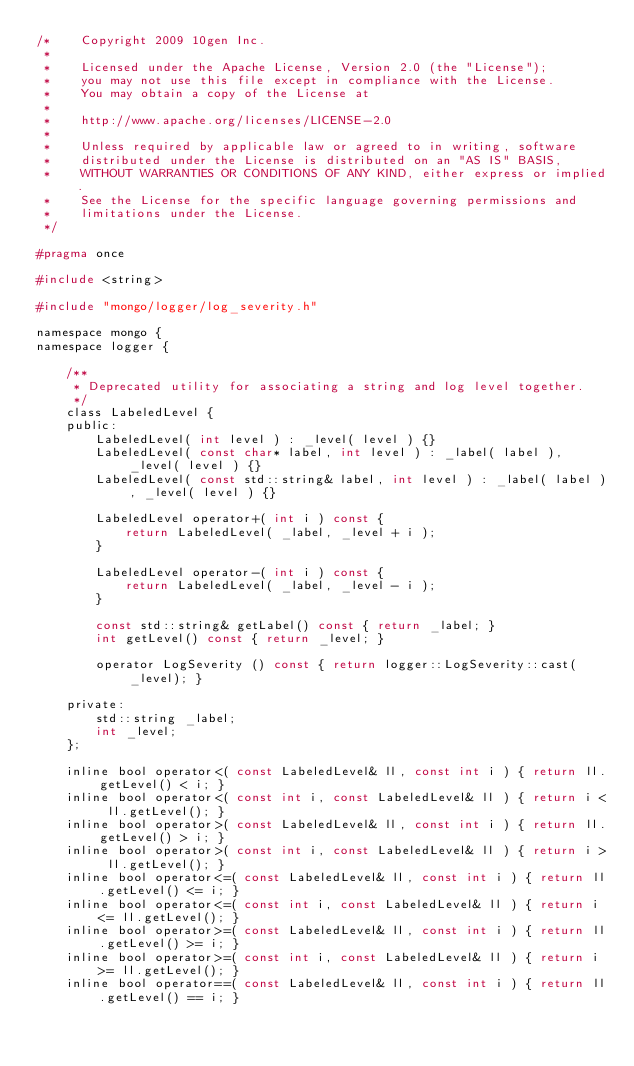<code> <loc_0><loc_0><loc_500><loc_500><_C_>/*    Copyright 2009 10gen Inc.
 *
 *    Licensed under the Apache License, Version 2.0 (the "License");
 *    you may not use this file except in compliance with the License.
 *    You may obtain a copy of the License at
 *
 *    http://www.apache.org/licenses/LICENSE-2.0
 *
 *    Unless required by applicable law or agreed to in writing, software
 *    distributed under the License is distributed on an "AS IS" BASIS,
 *    WITHOUT WARRANTIES OR CONDITIONS OF ANY KIND, either express or implied.
 *    See the License for the specific language governing permissions and
 *    limitations under the License.
 */

#pragma once

#include <string>

#include "mongo/logger/log_severity.h"

namespace mongo {
namespace logger {

    /**
     * Deprecated utility for associating a string and log level together.
     */
    class LabeledLevel {
    public:
        LabeledLevel( int level ) : _level( level ) {}
        LabeledLevel( const char* label, int level ) : _label( label ), _level( level ) {}
        LabeledLevel( const std::string& label, int level ) : _label( label ), _level( level ) {}

        LabeledLevel operator+( int i ) const {
            return LabeledLevel( _label, _level + i );
        }

        LabeledLevel operator-( int i ) const {
            return LabeledLevel( _label, _level - i );
        }

        const std::string& getLabel() const { return _label; }
        int getLevel() const { return _level; }

        operator LogSeverity () const { return logger::LogSeverity::cast(_level); }

    private:
        std::string _label;
        int _level;
    };

    inline bool operator<( const LabeledLevel& ll, const int i ) { return ll.getLevel() < i; }
    inline bool operator<( const int i, const LabeledLevel& ll ) { return i < ll.getLevel(); }
    inline bool operator>( const LabeledLevel& ll, const int i ) { return ll.getLevel() > i; }
    inline bool operator>( const int i, const LabeledLevel& ll ) { return i > ll.getLevel(); }
    inline bool operator<=( const LabeledLevel& ll, const int i ) { return ll.getLevel() <= i; }
    inline bool operator<=( const int i, const LabeledLevel& ll ) { return i <= ll.getLevel(); }
    inline bool operator>=( const LabeledLevel& ll, const int i ) { return ll.getLevel() >= i; }
    inline bool operator>=( const int i, const LabeledLevel& ll ) { return i >= ll.getLevel(); }
    inline bool operator==( const LabeledLevel& ll, const int i ) { return ll.getLevel() == i; }</code> 